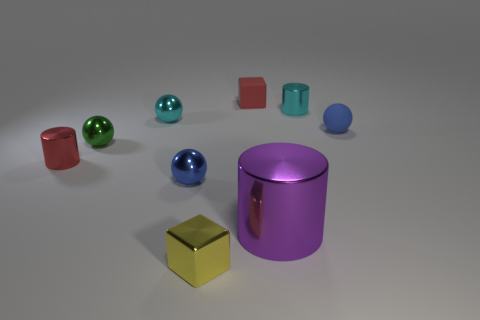Subtract all green spheres. How many spheres are left? 3 Subtract 3 balls. How many balls are left? 1 Subtract all cyan spheres. How many spheres are left? 3 Subtract all cubes. How many objects are left? 7 Subtract 1 purple cylinders. How many objects are left? 8 Subtract all red balls. Subtract all green cylinders. How many balls are left? 4 Subtract all cyan spheres. How many yellow cubes are left? 1 Subtract all small red metal balls. Subtract all yellow cubes. How many objects are left? 8 Add 1 metallic cylinders. How many metallic cylinders are left? 4 Add 7 cubes. How many cubes exist? 9 